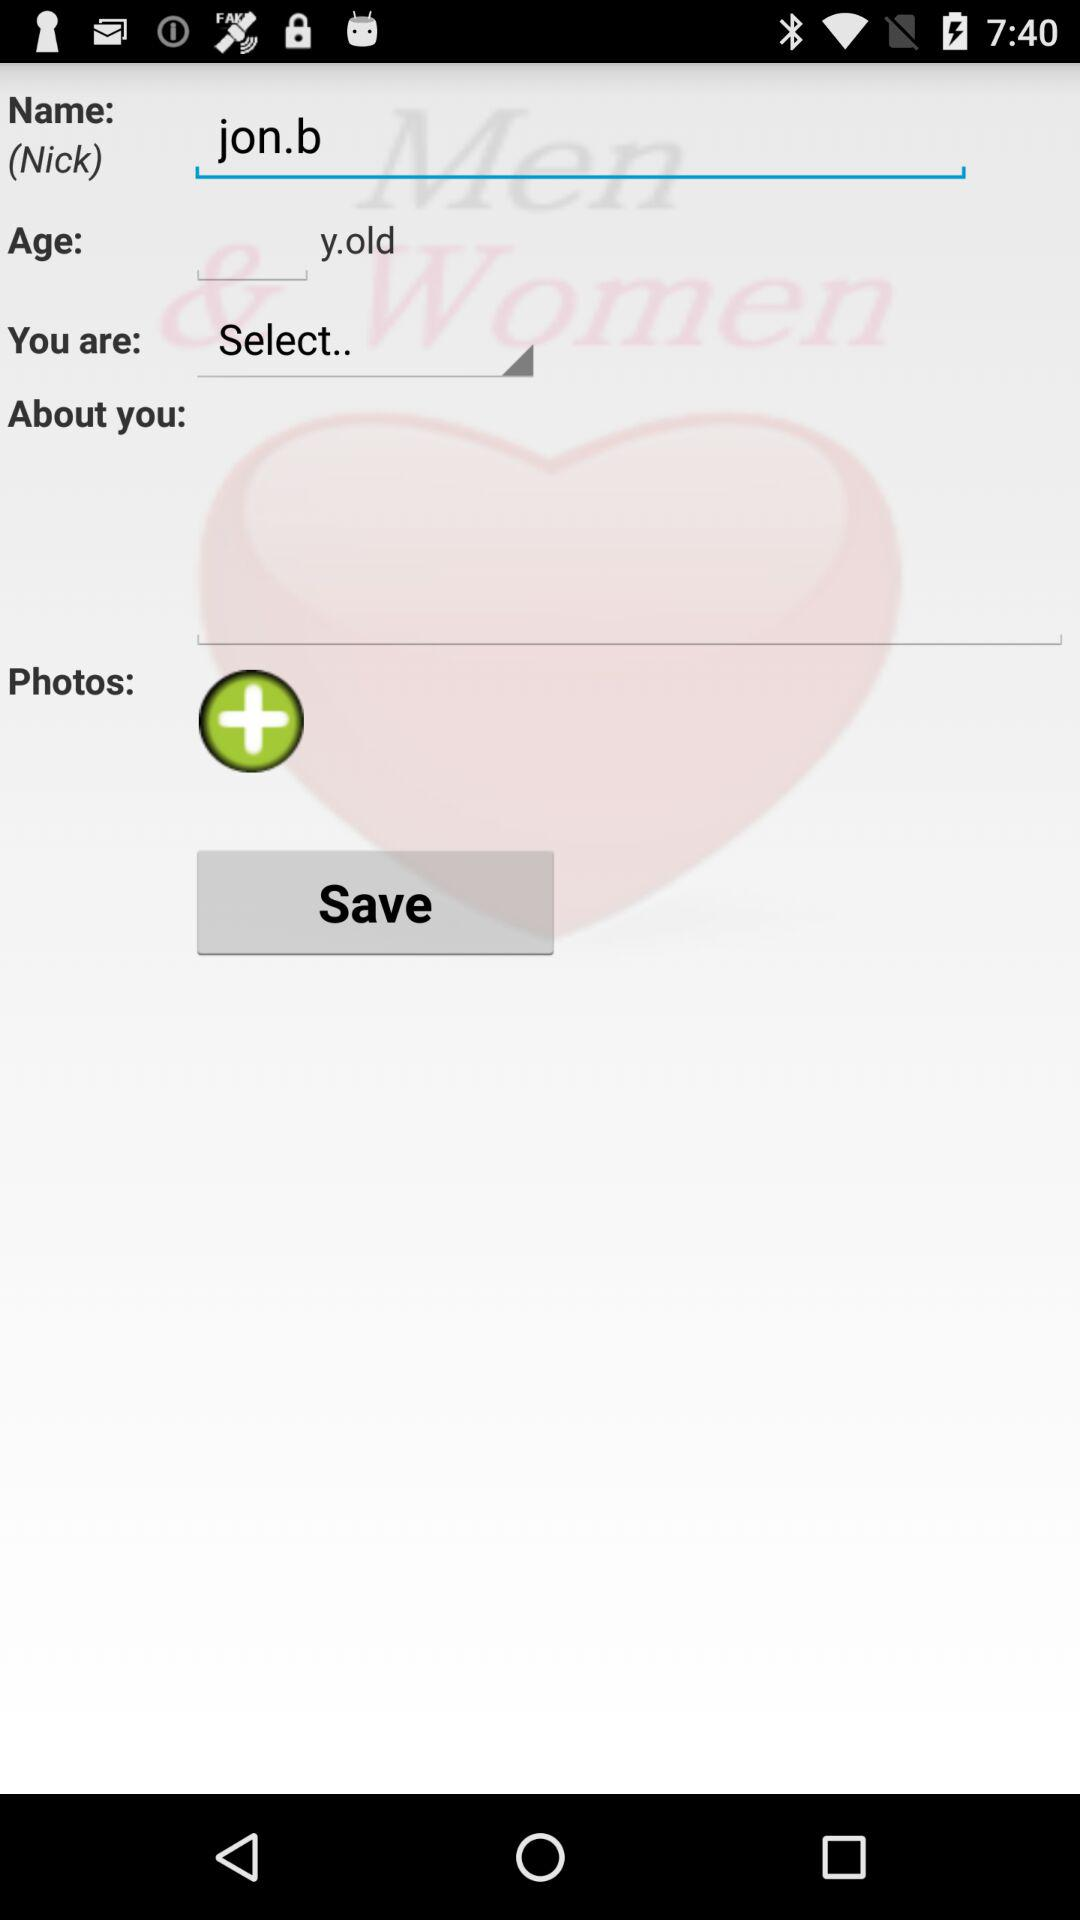What is the username? The username is "jon.b". 